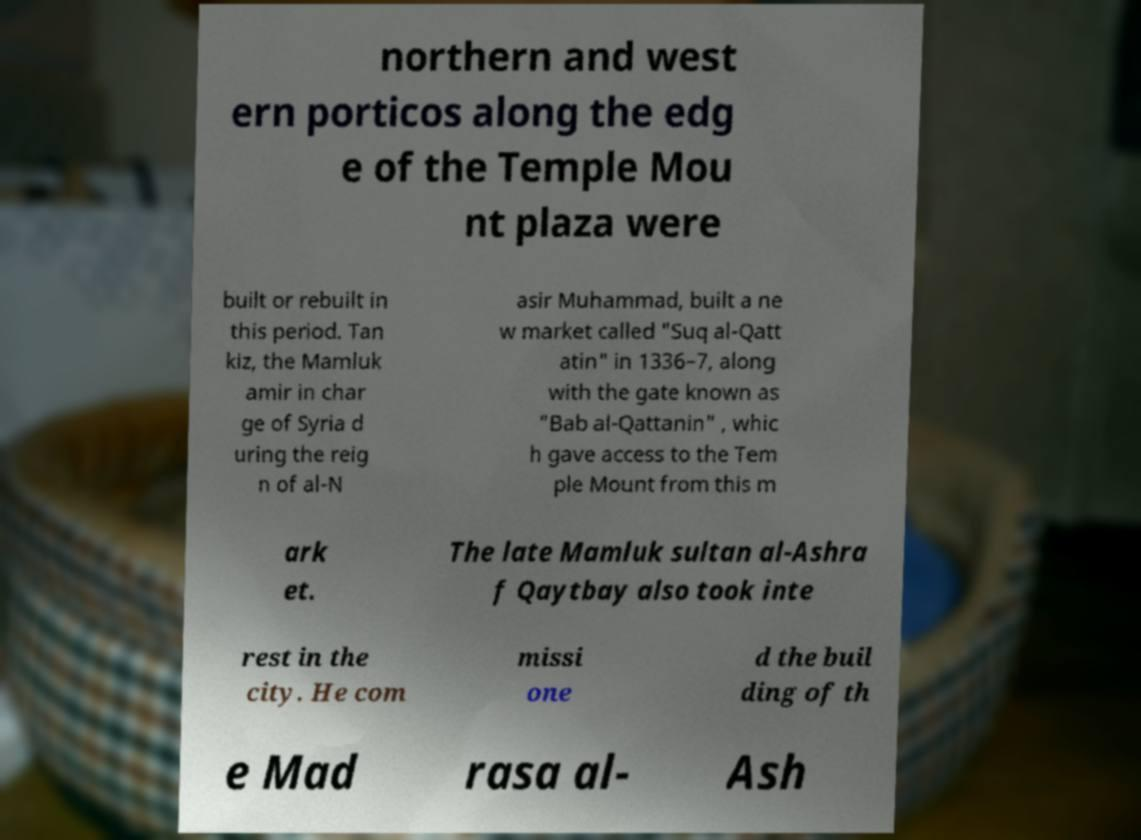Can you accurately transcribe the text from the provided image for me? northern and west ern porticos along the edg e of the Temple Mou nt plaza were built or rebuilt in this period. Tan kiz, the Mamluk amir in char ge of Syria d uring the reig n of al-N asir Muhammad, built a ne w market called "Suq al-Qatt atin" in 1336–7, along with the gate known as "Bab al-Qattanin" , whic h gave access to the Tem ple Mount from this m ark et. The late Mamluk sultan al-Ashra f Qaytbay also took inte rest in the city. He com missi one d the buil ding of th e Mad rasa al- Ash 